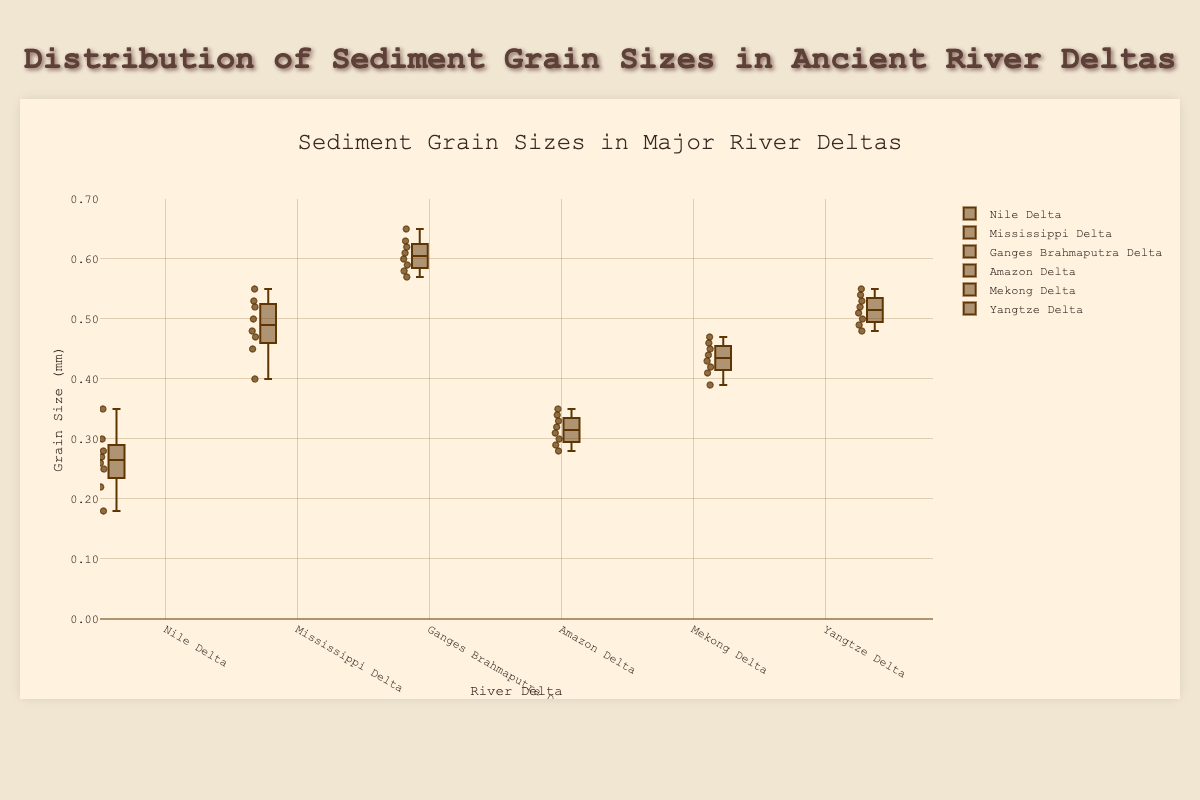What's the median grain size in the Nile Delta? The median value is the middle value of an ordered list. The grain sizes in the Nile Delta are [0.18, 0.22, 0.25, 0.26, 0.27, 0.28, 0.30, 0.35]. The middle values are 0.26 and 0.27, so the median is (0.26+0.27)/2 = 0.265.
Answer: 0.265 Which delta has the highest range of sediment grain sizes? The range is the difference between the maximum and minimum values. For each delta, find the maximum and minimum grain sizes and compute their range. The ranges are: Nile (0.35-0.18 = 0.17), Mississippi (0.55-0.40 = 0.15), Ganges-Brahmaputra (0.65-0.57 = 0.08), Amazon (0.35-0.28 = 0.07), Mekong (0.47-0.39 = 0.08), Yangtze (0.55-0.48 = 0.07). The Nile Delta has the highest range of 0.17.
Answer: Nile Delta What is the interquartile range (IQR) for the Ganges-Brahmaputra Delta? The IQR is the difference between the third quartile (Q3) and the first quartile (Q1). The data for Ganges-Brahmaputra ordered is [0.57, 0.58, 0.59, 0.60, 0.61, 0.62, 0.63, 0.65]. Q1 is the median of the first half (0.58+0.59)/2 = 0.585, and Q3 is the median of the second half (0.62+0.63)/2 = 0.625. The IQR is 0.625 - 0.585 = 0.04.
Answer: 0.04 Which delta has the smallest median grain size? To find the smallest median, look at the middle value (median) of each delta’s ordered grain size list. Nile (0.265), Mississippi (0.49), Ganges-Brahmaputra (0.61), Amazon (0.315), Mekong (0.435), Yangtze (0.515). The Nile Delta has the smallest median grain size of 0.265.
Answer: Nile Delta For the Amazon Delta, what is the difference between the smallest and largest grain size? The smallest grain size in the Amazon Delta is 0.28, and the largest is 0.35. The difference is 0.35 - 0.28 = 0.07.
Answer: 0.07 Which delta shows the least variation in grain sizes? To determine the delta with the least variation, compare the ranges of grain sizes. The ranges are: Nile (0.17), Mississippi (0.15), Ganges-Brahmaputra (0.08), Amazon (0.07), Mekong (0.08), Yangtze (0.07). The Amazon and Yangtze Deltas both show the least variation with a range of 0.07.
Answer: Amazon Delta, Yangtze Delta How does the median grain size of the Yangtze Delta compare to that of the Mississippi Delta? The median grain size for the Yangtze Delta is 0.515 and for the Mississippi Delta is 0.49. Comparing, 0.515 is greater than 0.49.
Answer: Yangtze Delta > Mississippi Delta 